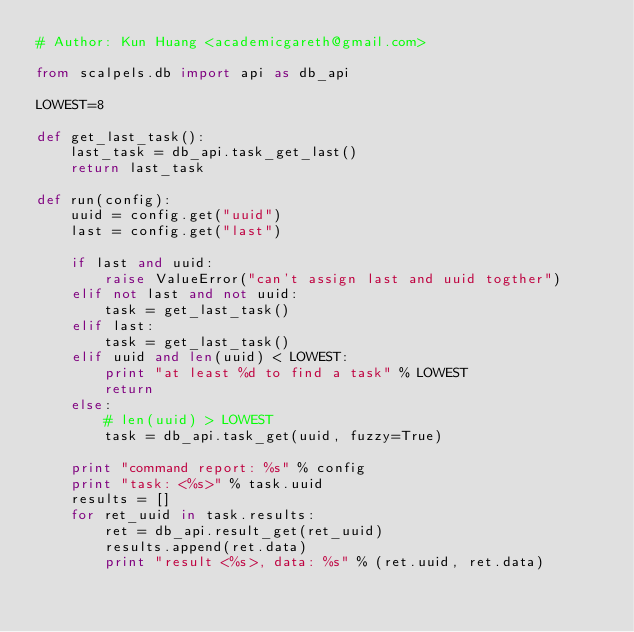<code> <loc_0><loc_0><loc_500><loc_500><_Python_># Author: Kun Huang <academicgareth@gmail.com>

from scalpels.db import api as db_api

LOWEST=8

def get_last_task():
    last_task = db_api.task_get_last()
    return last_task

def run(config):
    uuid = config.get("uuid")
    last = config.get("last")

    if last and uuid:
        raise ValueError("can't assign last and uuid togther")
    elif not last and not uuid:
        task = get_last_task()
    elif last:
        task = get_last_task()
    elif uuid and len(uuid) < LOWEST:
        print "at least %d to find a task" % LOWEST
        return
    else:
        # len(uuid) > LOWEST
        task = db_api.task_get(uuid, fuzzy=True)

    print "command report: %s" % config
    print "task: <%s>" % task.uuid
    results = []
    for ret_uuid in task.results:
        ret = db_api.result_get(ret_uuid)
        results.append(ret.data)
        print "result <%s>, data: %s" % (ret.uuid, ret.data)
</code> 